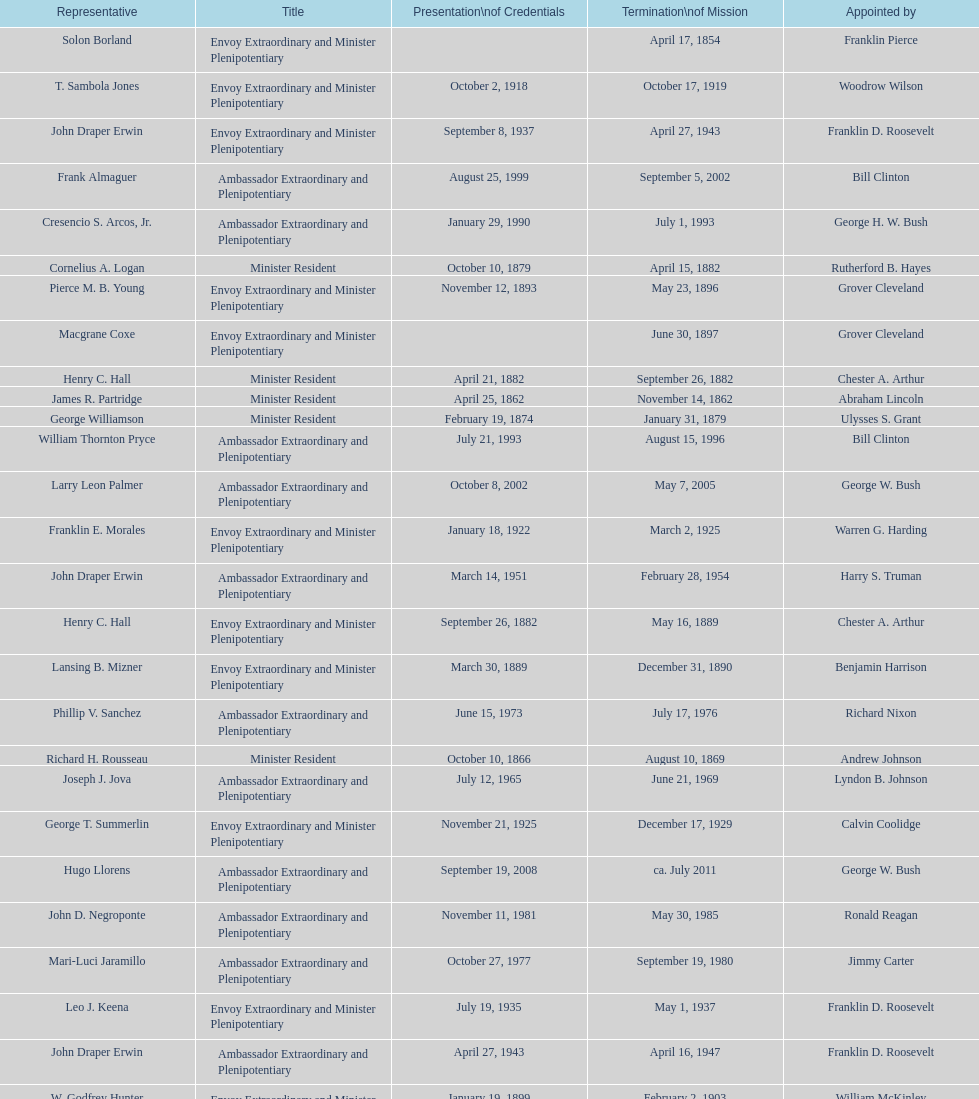Who is the only ambassadors to honduras appointed by barack obama? Lisa Kubiske. 